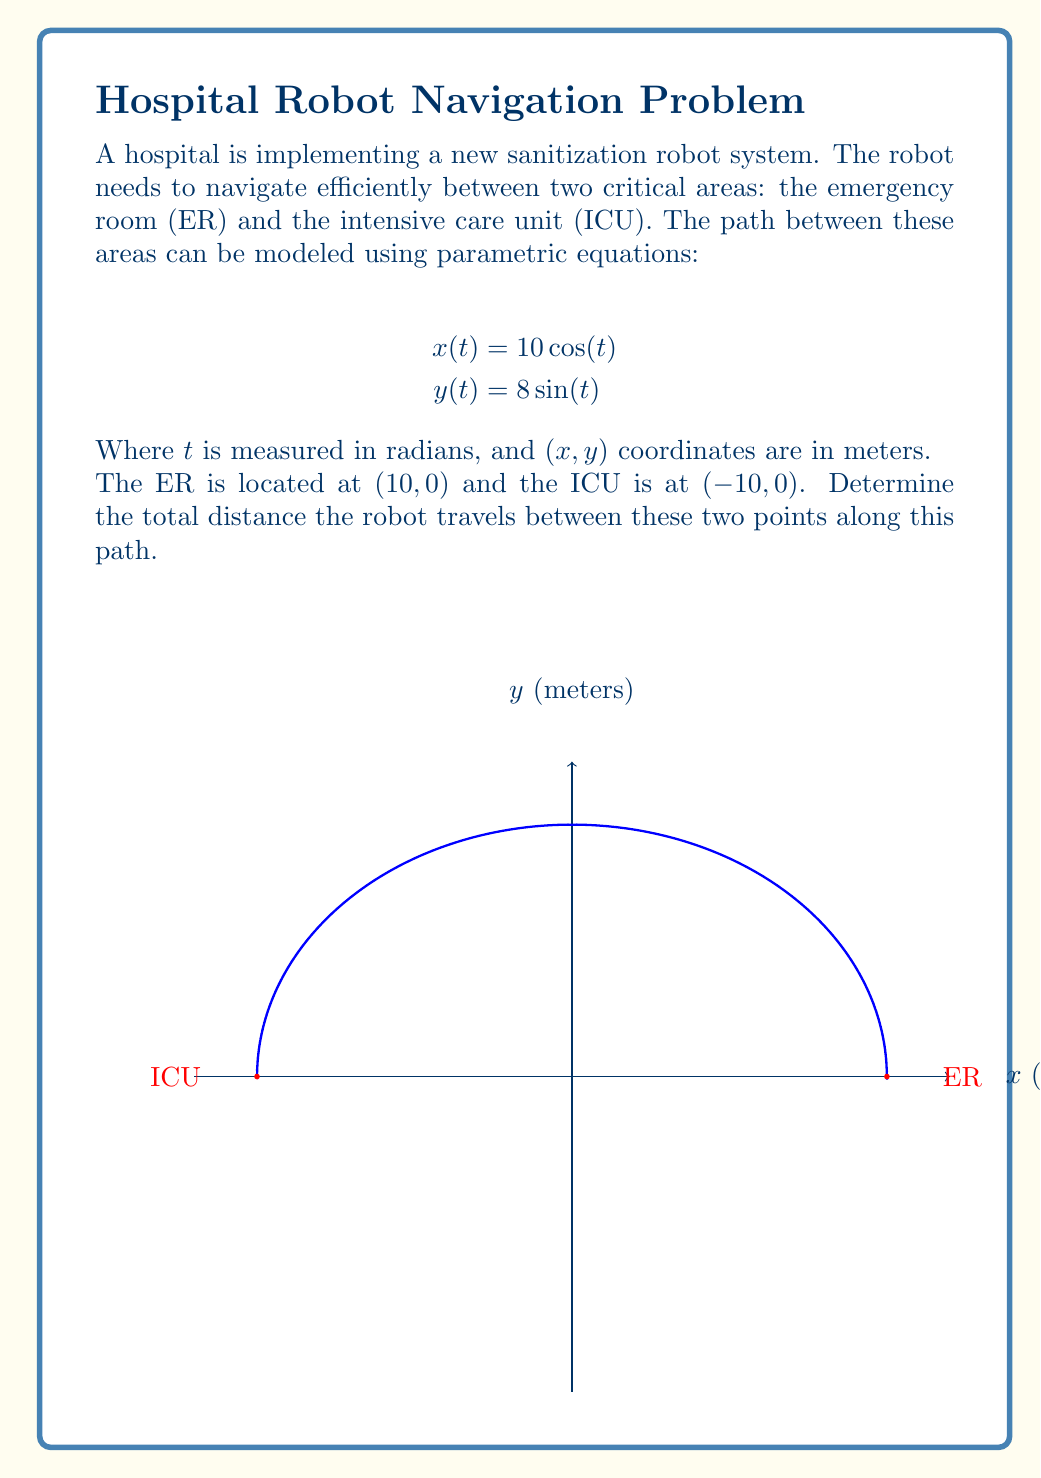Provide a solution to this math problem. Let's approach this step-by-step:

1) The parametric equations given are:
   $$x(t) = 10\cos(t)$$
   $$y(t) = 8\sin(t)$$

2) We need to find the arc length of this curve from $t=0$ to $t=\pi$, as these correspond to the ER $(10,0)$ and ICU $(-10,0)$ respectively.

3) The formula for arc length of a parametric curve from $t=a$ to $t=b$ is:
   $$L = \int_a^b \sqrt{\left(\frac{dx}{dt}\right)^2 + \left(\frac{dy}{dt}\right)^2} dt$$

4) Let's find $\frac{dx}{dt}$ and $\frac{dy}{dt}$:
   $$\frac{dx}{dt} = -10\sin(t)$$
   $$\frac{dy}{dt} = 8\cos(t)$$

5) Substituting into the arc length formula:
   $$L = \int_0^\pi \sqrt{(-10\sin(t))^2 + (8\cos(t))^2} dt$$

6) Simplify under the square root:
   $$L = \int_0^\pi \sqrt{100\sin^2(t) + 64\cos^2(t)} dt$$

7) Factor out the common term:
   $$L = \int_0^\pi \sqrt{4(25\sin^2(t) + 16\cos^2(t))} dt$$

8) Simplify further:
   $$L = 2\int_0^\pi \sqrt{25\sin^2(t) + 16\cos^2(t)} dt$$

9) This integral doesn't have an elementary antiderivative. We need to use numerical methods or elliptic integrals to evaluate it. Using a calculator or computer algebra system, we get:

   $$L \approx 28.81 \text{ meters}$$

Thus, the robot travels approximately 28.81 meters between the ER and ICU along this path.
Answer: 28.81 meters 